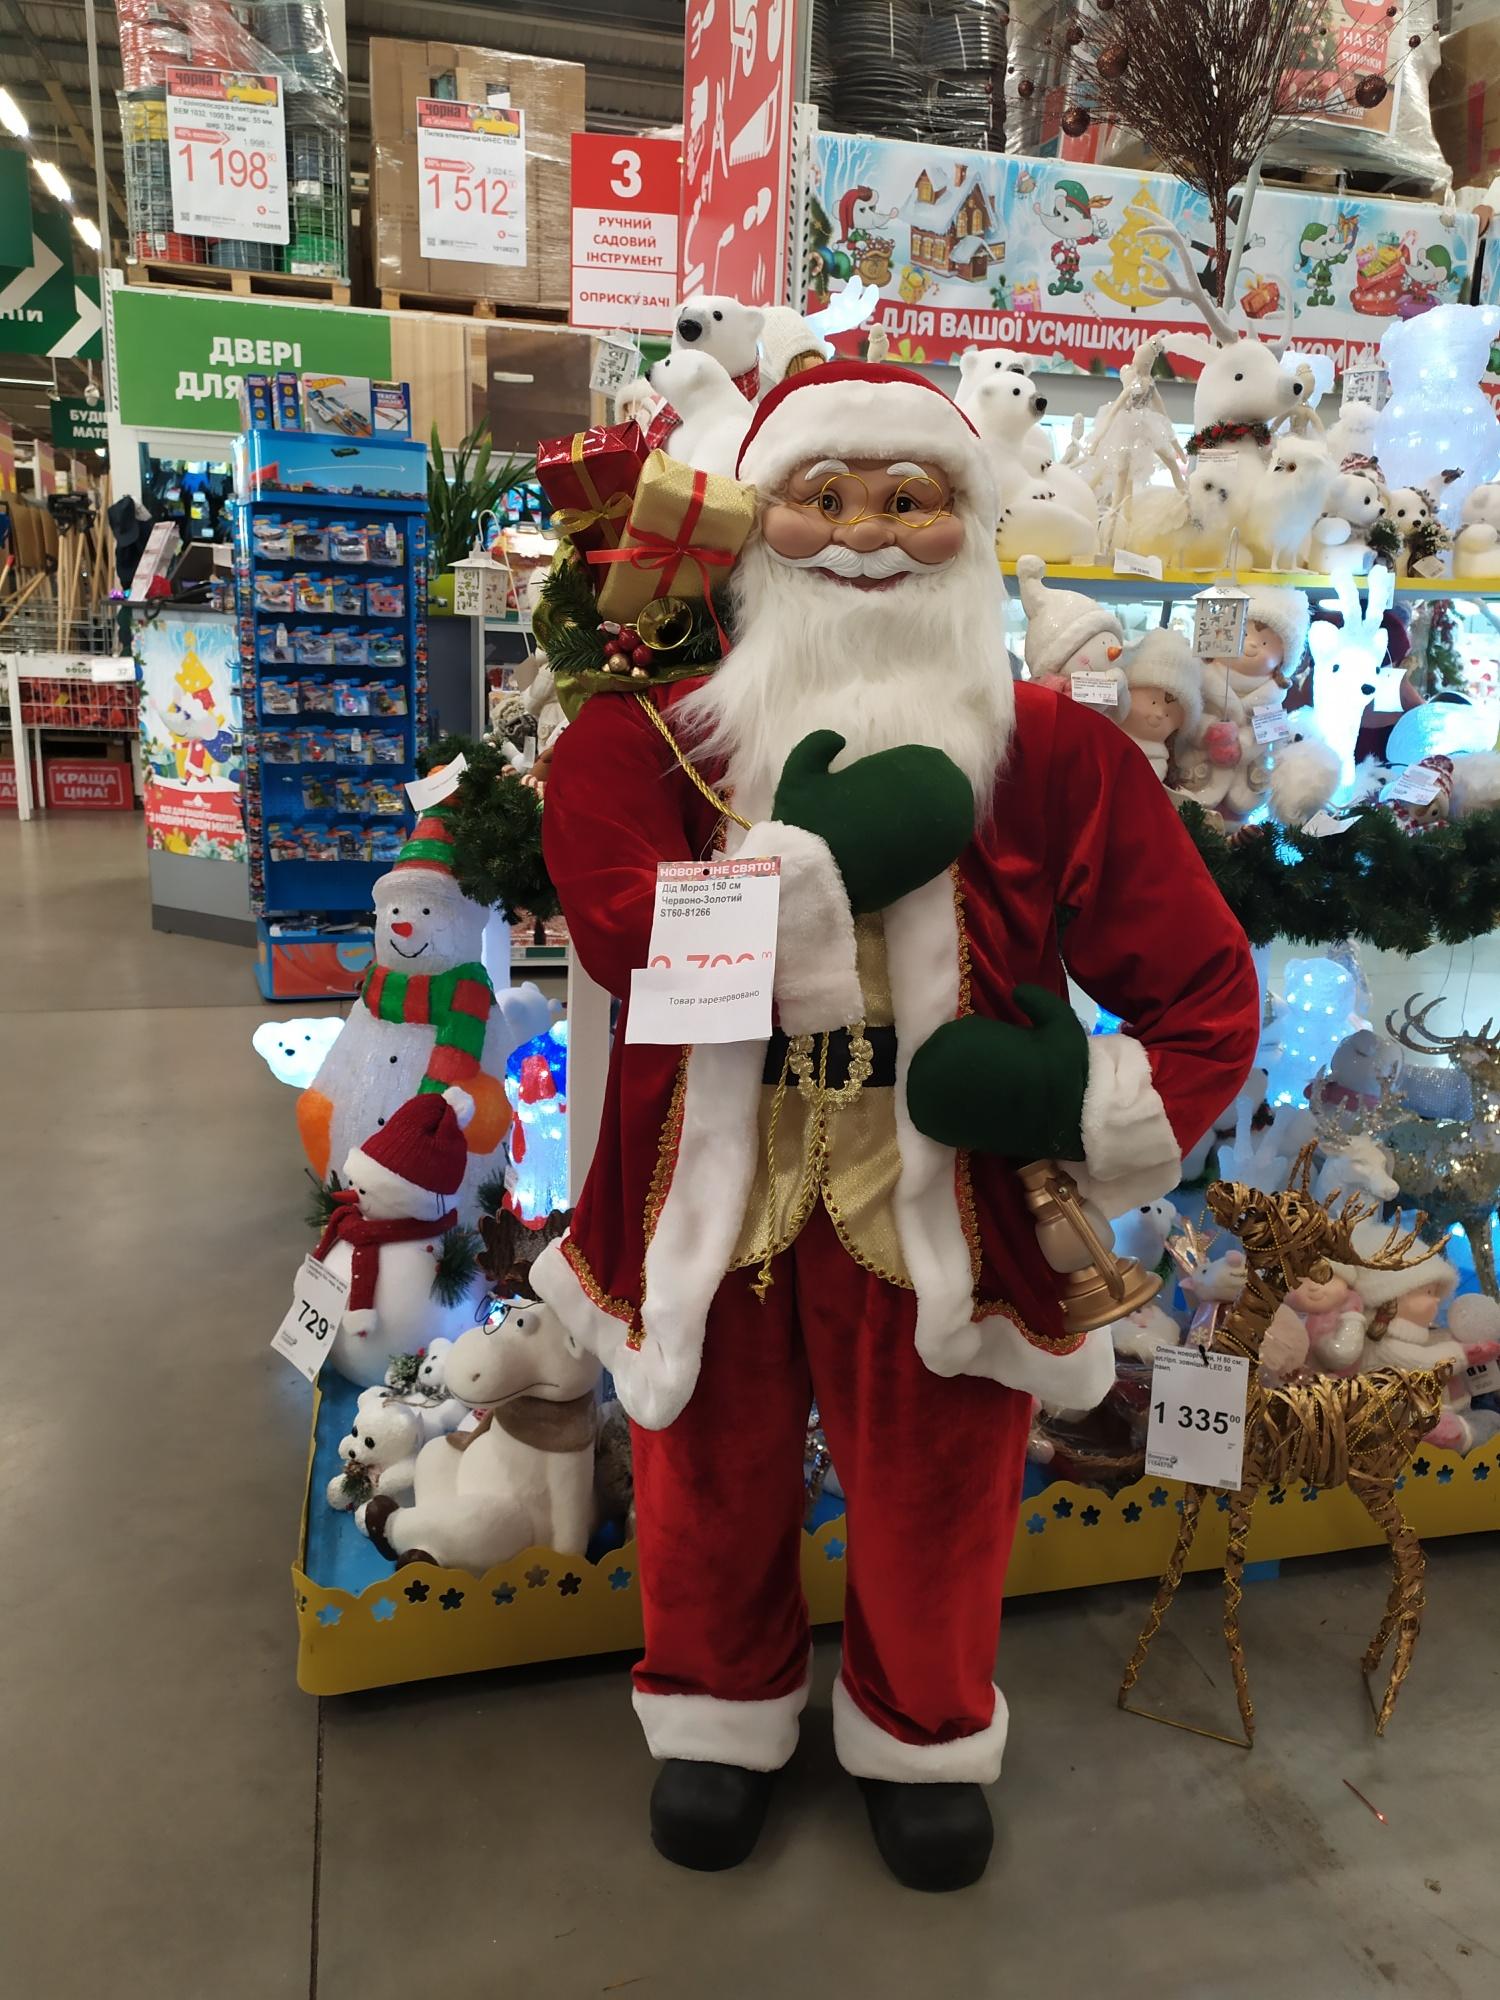Describe the central figure in the image in great detail. The central figure in the image is a life-size Santa Claus mannequin. Santa is dressed in a classic Christmas outfit: a red, velvet suit featuring luxurious white fur trim on the sleeves, collar, and hem. His trousers are also red and trimmed with white fur. He sports black gloves and matching black boots. Santa's white beard looks fluffy and well-groomed, and his rosy cheeks give him a jolly appearance. He is holding a golden bell in one hand and what appears to be a detailed list in the other. Over his shoulder is a green sack, which contains a bright, gift-wrapped present and festive greenery. The overall appearance of Santa Claus exudes warmth, joy, and the festive spirit of Christmas. Can you tell me about the decorations in the background? Absolutely! In the background behind the Santa Claus figure, there is an array of Christmas decorations. There are numerous plush stuffed animals, including polar bears, snowmen, and festive figures adorned with holiday accessories like scarves and hats. The entire display is brightly lit with Christmas lights, ranging from cool blues to warm whites, which create a cozy, festive ambiance. On the right side, there is a striking reindeer decoration made from golden material, adding a touch of elegance to the display. The shelves are packed with various other holiday items, enhancing the overall theme of festivity and joy. What might Santa be thinking as he stands there? Santa might be thinking about all the joy and cheer he brings to children and adults alike during the holiday season. He might be reminiscing about the numerous letters he has received with wishes from children all over the world and feeling a sense of fulfillment in bringing those dreams to life. Perhaps he's also thinking about the preparations at his workshop in the North Pole, where elves are tirelessly crafting toys and gifts for Christmas Eve. The festive atmosphere surrounding him likely fills him with pride and a deep sense of tradition, knowing he is a beloved symbol of Christmas spirit and generosity. 